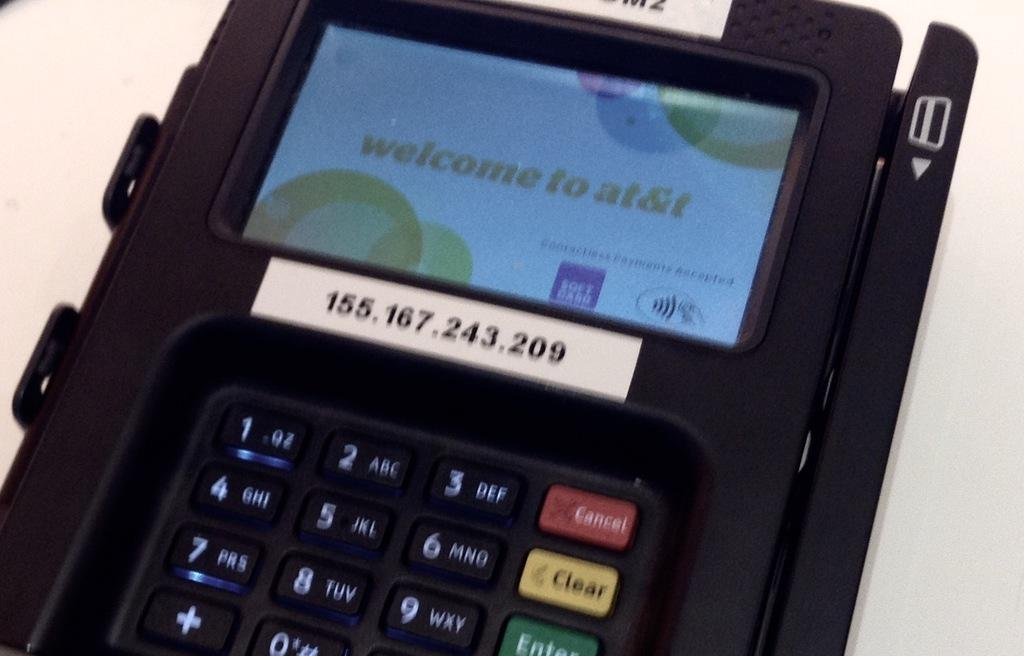<image>
Relay a brief, clear account of the picture shown. A credit card reader with a welcome to at&t sign on the screen 